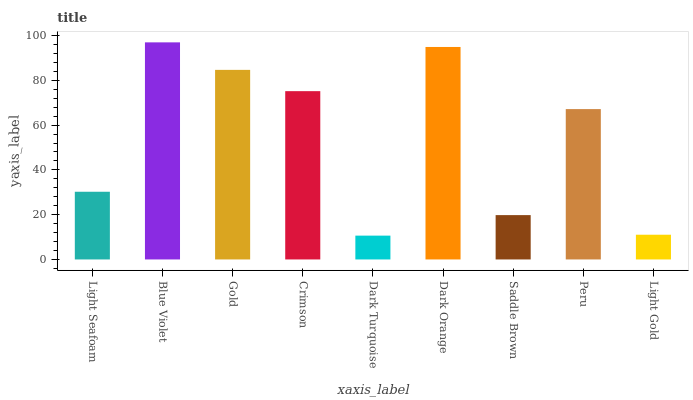Is Dark Turquoise the minimum?
Answer yes or no. Yes. Is Blue Violet the maximum?
Answer yes or no. Yes. Is Gold the minimum?
Answer yes or no. No. Is Gold the maximum?
Answer yes or no. No. Is Blue Violet greater than Gold?
Answer yes or no. Yes. Is Gold less than Blue Violet?
Answer yes or no. Yes. Is Gold greater than Blue Violet?
Answer yes or no. No. Is Blue Violet less than Gold?
Answer yes or no. No. Is Peru the high median?
Answer yes or no. Yes. Is Peru the low median?
Answer yes or no. Yes. Is Saddle Brown the high median?
Answer yes or no. No. Is Dark Orange the low median?
Answer yes or no. No. 